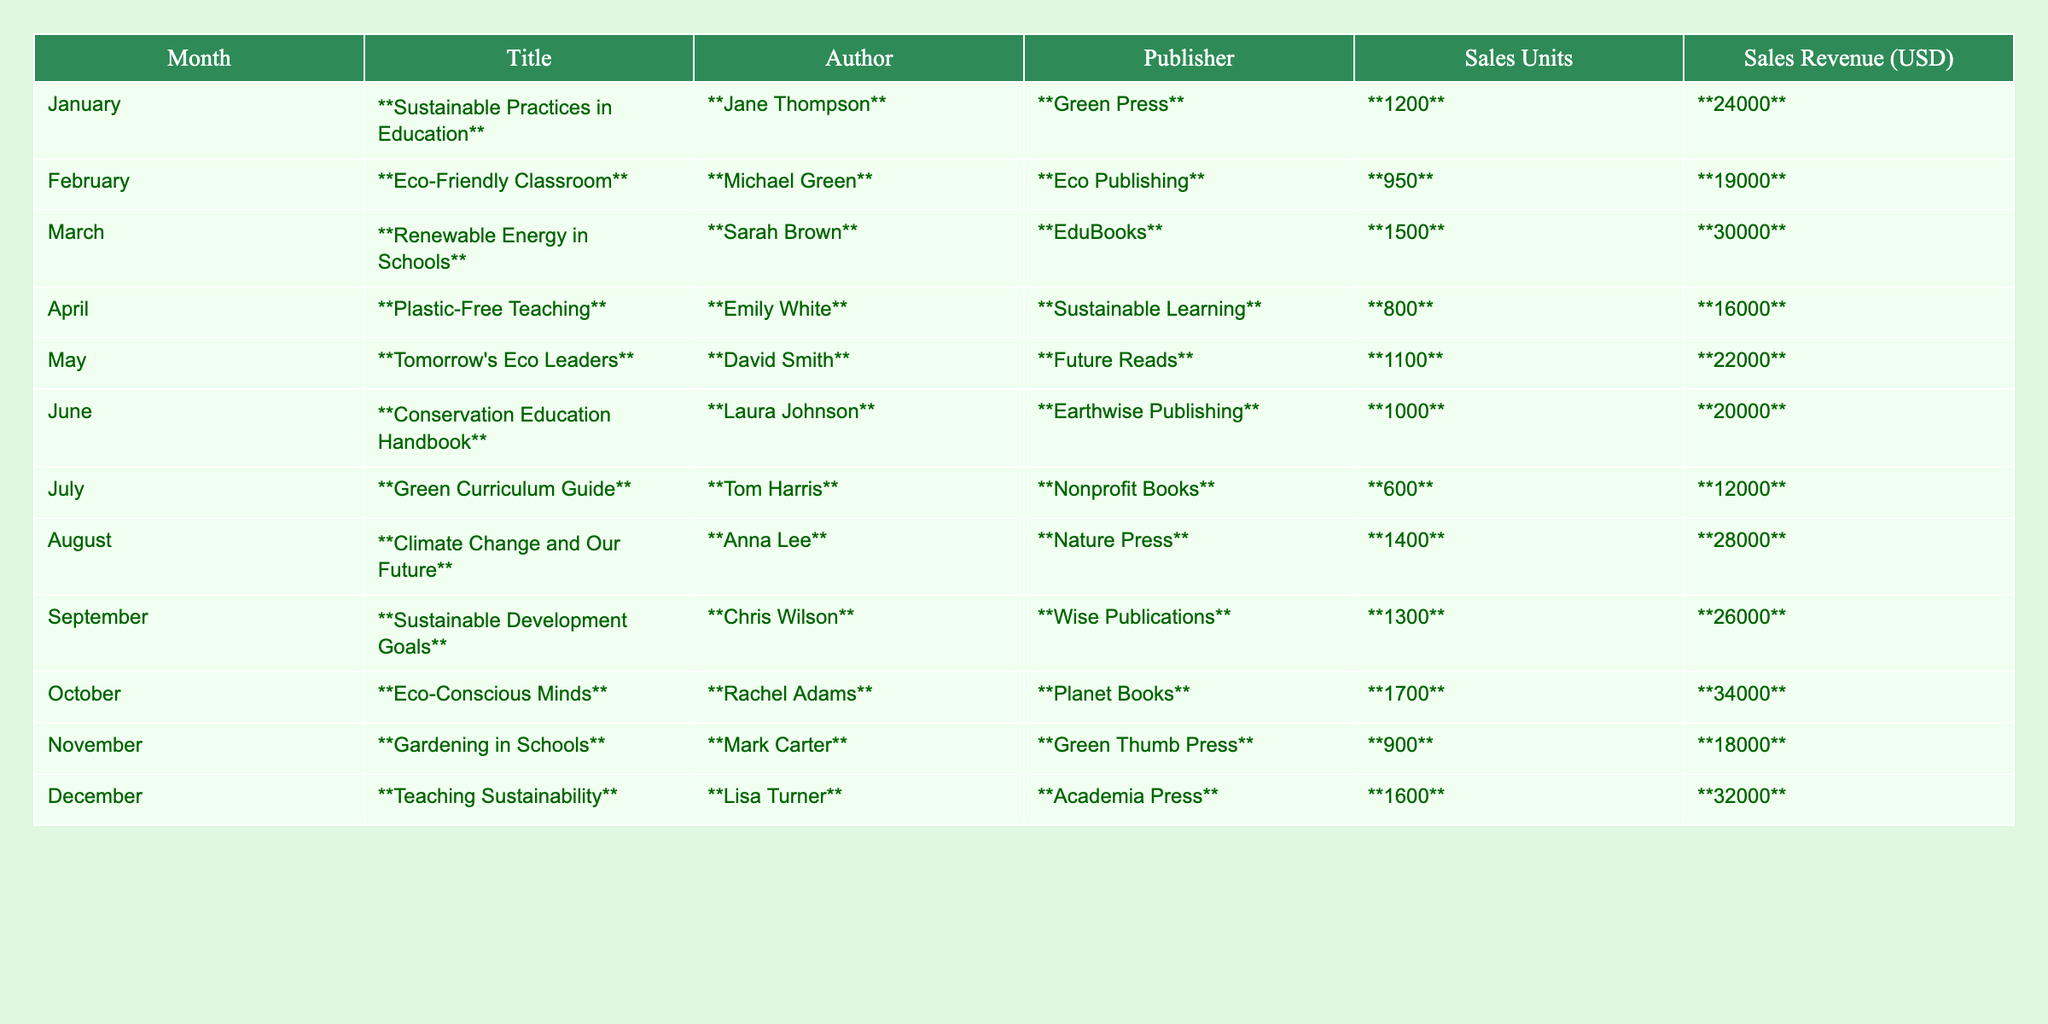What is the total sales revenue for the month of April? In April, the sales revenue is listed as **16,000** USD, which is a direct retrieval from the table.
Answer: 16,000 USD Which textbook had the highest sales units? The textbook with the highest sales units is **Eco-Conscious Minds**, with **1,700** units sold, as shown in the table.
Answer: Eco-Conscious Minds What is the average sales revenue for the months of January to March? The sales revenue for January is 24,000 USD, February is 19,000 USD, and March is 30,000 USD. Adding these gives 24,000 + 19,000 + 30,000 = 73,000 USD. There are 3 months, so the average is 73,000 / 3 = **24,333.33** USD.
Answer: 24,333.33 USD How many textbooks sold in June compared to February? In June, **1,000** units were sold, and in February, **950** units were sold. The difference in sales is 1,000 - 950 = **50** units more sold in June.
Answer: 50 units What percentage of total sales revenue does the book "Teaching Sustainability" contribute? The total sales revenue for all books is the sum of each month's revenue, which is 24000 + 19000 + 30000 + 16000 + 22000 + 20000 + 12000 + 28000 + 26000 + 34000 + 18000 + 32000 = **240,000** USD. The revenue from "Teaching Sustainability" is **32,000** USD, so the percentage is (32,000 / 240,000) * 100 = **13.33%**.
Answer: 13.33% Is there a textbook written by "Sarah Brown"? Yes, the textbook **Renewable Energy in Schools** is authored by **Sarah Brown**, as indicated in the author column of the table.
Answer: Yes Which month had sales units below 1,000? The months with sales units below 1,000 are April with **800** units and July with **600** units. These values can be seen in the sales units column.
Answer: April and July What was the total sales units for the year? To find the total sales units for the year, we add all the units sold each month: 1200 + 950 + 1500 + 800 + 1100 + 1000 + 600 + 1400 + 1300 + 1700 + 900 + 1600 = **13,100** units.
Answer: 13,100 units Which textbook was published by "Eco Publishing"? The textbook published by **Eco Publishing** is **Eco-Friendly Classroom**, as noted in the publisher column of the table.
Answer: Eco-Friendly Classroom Did more units sell in August compared to May? In August, **1,400** units were sold, and in May, **1,100** units were sold. Since 1,400 is greater than 1,100, the answer is yes.
Answer: Yes What are the total sales revenue and units for the two highest-selling titles in October and March? In October, **1,700** units were sold for **34,000** USD, and in March, **1,500** units were sold for **30,000** USD. Adding these yields total sales units of 1,700 + 1,500 = **3,200** units and total sales revenue of 34,000 + 30,000 = **64,000** USD.
Answer: 3,200 units and 64,000 USD 